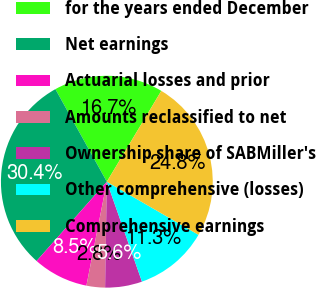<chart> <loc_0><loc_0><loc_500><loc_500><pie_chart><fcel>for the years ended December<fcel>Net earnings<fcel>Actuarial losses and prior<fcel>Amounts reclassified to net<fcel>Ownership share of SABMiller's<fcel>Other comprehensive (losses)<fcel>Comprehensive earnings<nl><fcel>16.67%<fcel>30.38%<fcel>8.45%<fcel>2.83%<fcel>5.64%<fcel>11.26%<fcel>24.76%<nl></chart> 